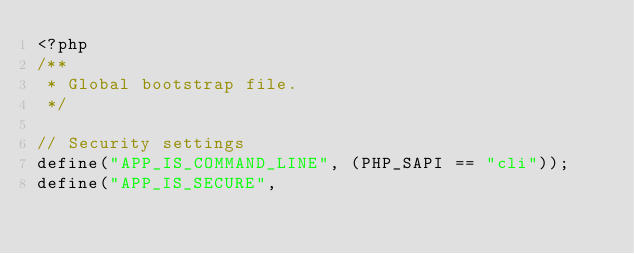<code> <loc_0><loc_0><loc_500><loc_500><_PHP_><?php
/**
 * Global bootstrap file.
 */

// Security settings
define("APP_IS_COMMAND_LINE", (PHP_SAPI == "cli"));
define("APP_IS_SECURE",</code> 